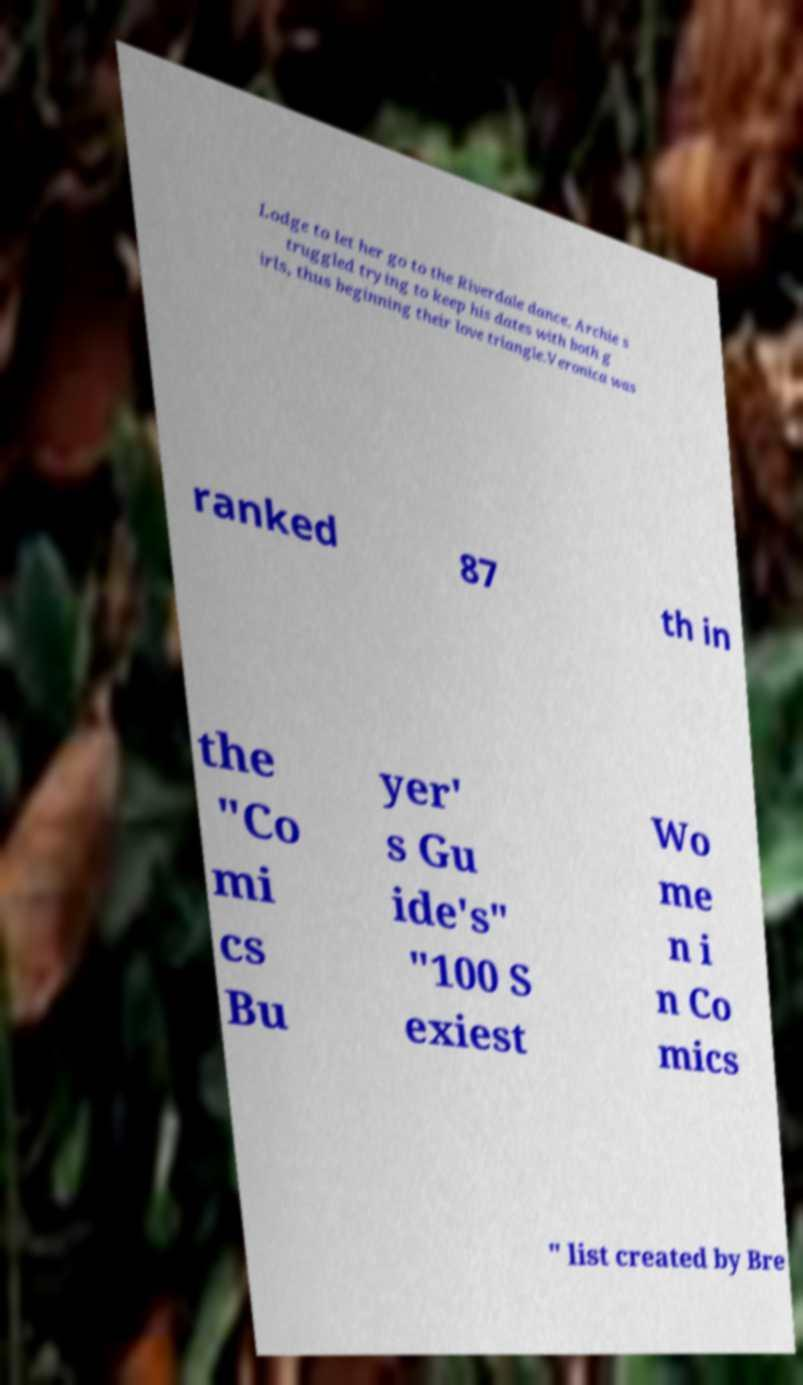I need the written content from this picture converted into text. Can you do that? Lodge to let her go to the Riverdale dance. Archie s truggled trying to keep his dates with both g irls, thus beginning their love triangle.Veronica was ranked 87 th in the "Co mi cs Bu yer' s Gu ide's" "100 S exiest Wo me n i n Co mics " list created by Bre 